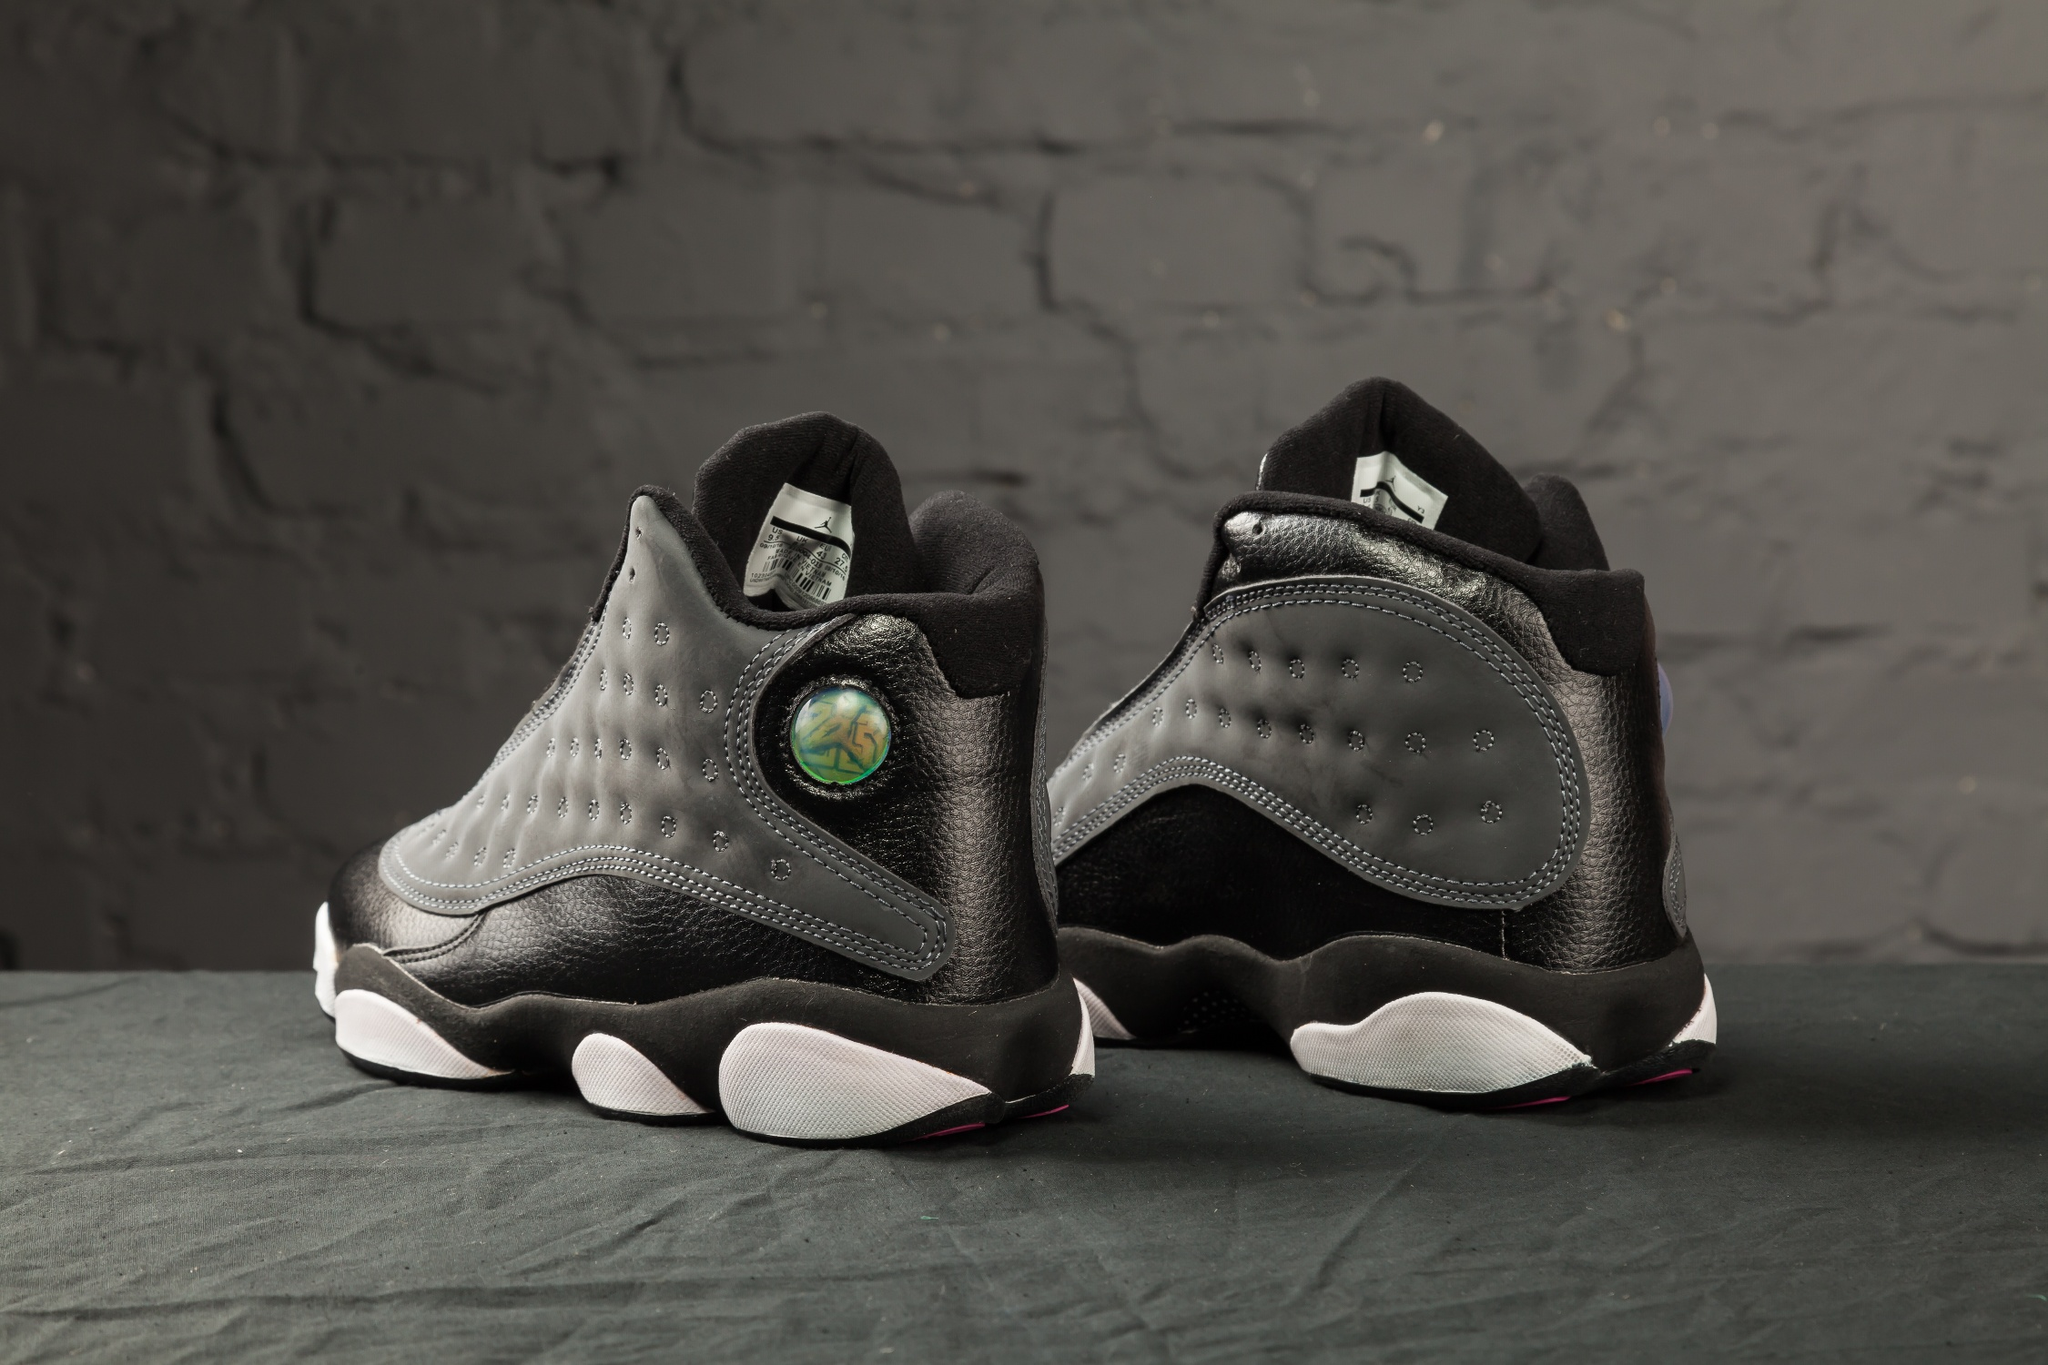Describe the following image. The image features a pair of black and gray high-top sneakers with an urban edge. The sneakers, one facing inward and one outward, showcase a sleek design with black leather and gray accents. The focal point is a holographic circular logo on the outer side of each shoe, which adds a futuristic touch. The white soles provide a strong contrast against the dark colorway and the black cloth-covered surface. The backdrop is a textured gray brick wall, lending a gritty, modern aesthetic to the overall composition. The interplay of different textures and the unique design elements make the sneakers stand out prominently. 